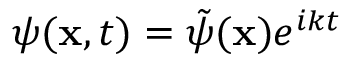Convert formula to latex. <formula><loc_0><loc_0><loc_500><loc_500>\psi ( x , t ) = \tilde { \psi } ( x ) e ^ { i k t }</formula> 